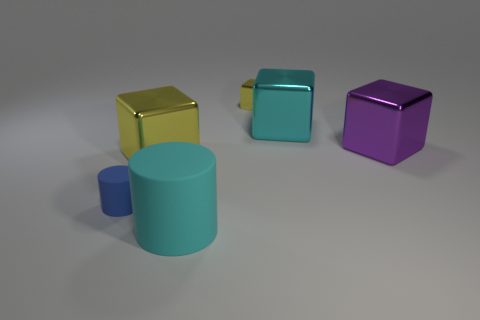What material is the object that is both in front of the big yellow thing and to the left of the large cylinder?
Provide a succinct answer. Rubber. There is a yellow cube that is the same material as the big yellow thing; what size is it?
Offer a very short reply. Small. There is a shiny thing that is the same color as the big matte thing; what is its size?
Provide a short and direct response. Large. There is a yellow metal block that is behind the metal cube to the right of the cyan thing to the right of the tiny yellow shiny object; how big is it?
Your response must be concise. Small. How many tiny objects are made of the same material as the large cyan cylinder?
Your response must be concise. 1. What number of matte things have the same size as the purple block?
Give a very brief answer. 1. What material is the big block on the left side of the small object on the right side of the cylinder in front of the small blue cylinder?
Make the answer very short. Metal. What number of things are either large metallic objects or yellow matte cylinders?
Keep it short and to the point. 3. What is the shape of the big cyan shiny thing?
Offer a very short reply. Cube. What is the shape of the cyan object that is in front of the rubber object that is to the left of the cyan cylinder?
Provide a short and direct response. Cylinder. 